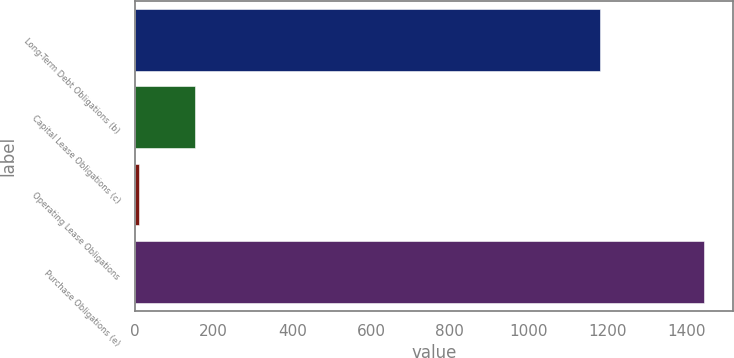Convert chart. <chart><loc_0><loc_0><loc_500><loc_500><bar_chart><fcel>Long-Term Debt Obligations (b)<fcel>Capital Lease Obligations (c)<fcel>Operating Lease Obligations<fcel>Purchase Obligations (e)<nl><fcel>1181.6<fcel>153.97<fcel>10.4<fcel>1446.1<nl></chart> 